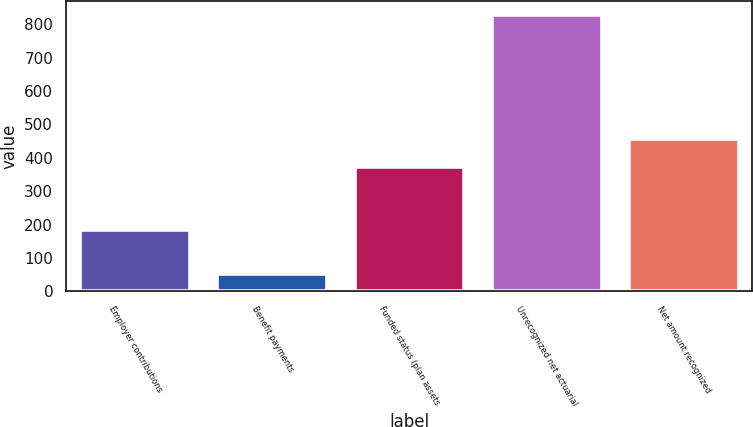Convert chart. <chart><loc_0><loc_0><loc_500><loc_500><bar_chart><fcel>Employer contributions<fcel>Benefit payments<fcel>Funded status (plan assets<fcel>Unrecognized net actuarial<fcel>Net amount recognized<nl><fcel>185<fcel>51<fcel>373<fcel>829<fcel>456<nl></chart> 